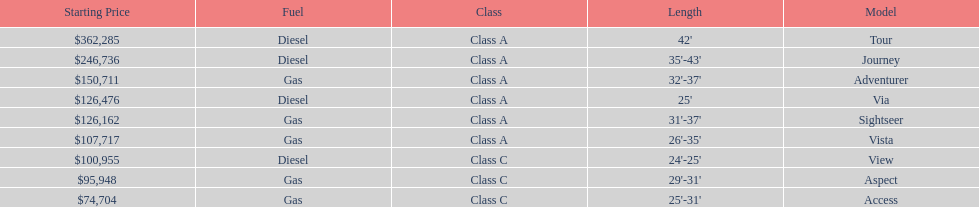Would you be able to parse every entry in this table? {'header': ['Starting Price', 'Fuel', 'Class', 'Length', 'Model'], 'rows': [['$362,285', 'Diesel', 'Class A', "42'", 'Tour'], ['$246,736', 'Diesel', 'Class A', "35'-43'", 'Journey'], ['$150,711', 'Gas', 'Class A', "32'-37'", 'Adventurer'], ['$126,476', 'Diesel', 'Class A', "25'", 'Via'], ['$126,162', 'Gas', 'Class A', "31'-37'", 'Sightseer'], ['$107,717', 'Gas', 'Class A', "26'-35'", 'Vista'], ['$100,955', 'Diesel', 'Class C', "24'-25'", 'View'], ['$95,948', 'Gas', 'Class C', "29'-31'", 'Aspect'], ['$74,704', 'Gas', 'Class C', "25'-31'", 'Access']]} Which model is at the top of the list with the highest starting price? Tour. 